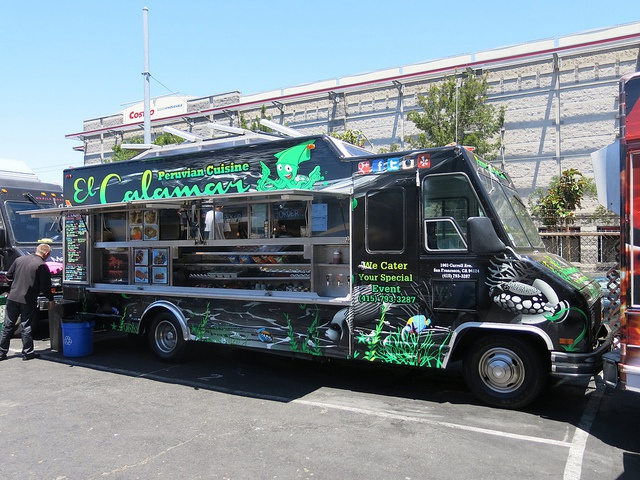Describe the objects in this image and their specific colors. I can see truck in lightblue, black, gray, blue, and darkgray tones, people in lightblue, black, and gray tones, and bottle in lightblue, gray, black, purple, and darkgray tones in this image. 